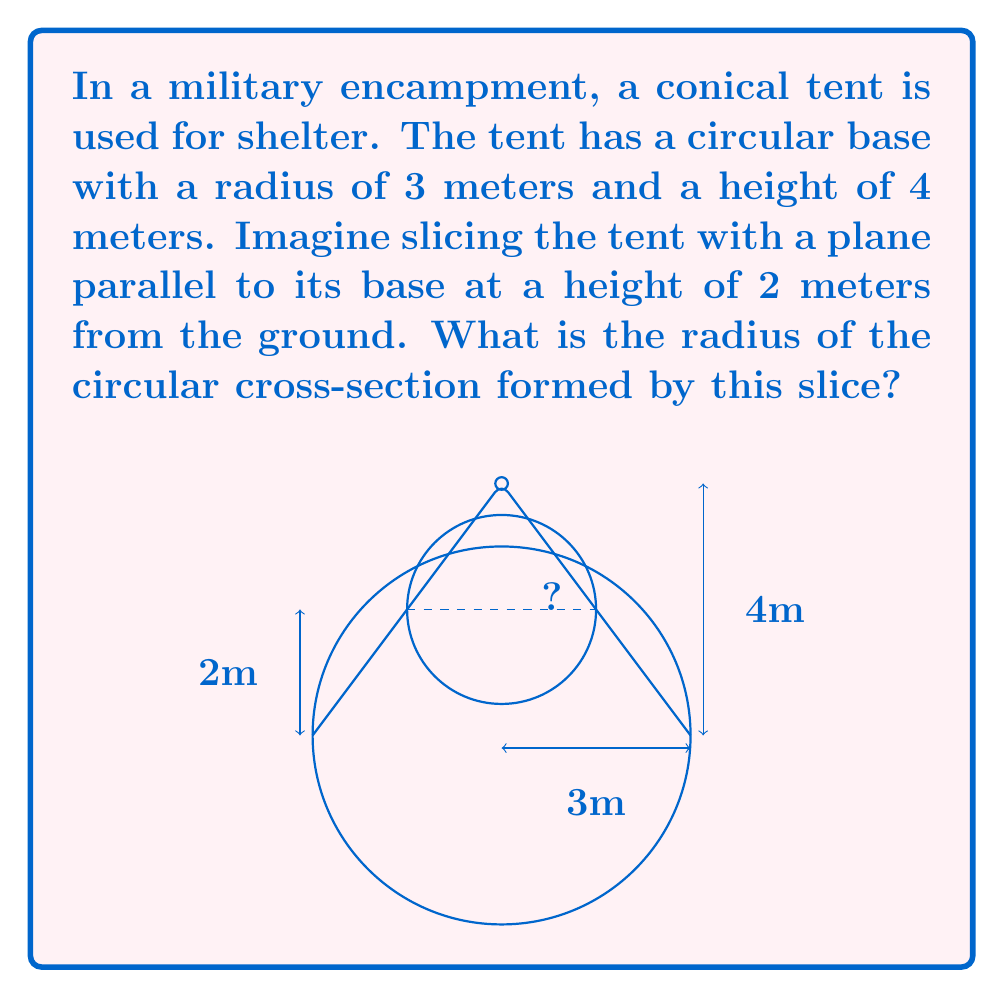Solve this math problem. To solve this problem, we'll use the concept of similar triangles in the conical tent:

1) First, let's identify the two similar triangles:
   - The large triangle formed by the entire tent
   - The smaller triangle formed by the portion of the tent above the slice

2) In the large triangle:
   - Base radius = 3 meters
   - Height = 4 meters

3) In the smaller triangle:
   - Base radius = unknown (let's call it $x$)
   - Height = 4 - 2 = 2 meters (since the slice is 2 meters from the ground)

4) The ratio of corresponding sides in similar triangles is constant. Let's use the ratio of heights to radii:

   $$\frac{\text{large height}}{\text{large radius}} = \frac{\text{small height}}{\text{small radius}}$$

5) Substituting the known values:

   $$\frac{4}{3} = \frac{2}{x}$$

6) Cross multiply:

   $$4x = 3 \cdot 2$$

7) Solve for $x$:

   $$x = \frac{3 \cdot 2}{4} = \frac{6}{4} = 1.5$$

Therefore, the radius of the circular cross-section is 1.5 meters.
Answer: 1.5 meters 